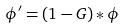Convert formula to latex. <formula><loc_0><loc_0><loc_500><loc_500>\phi ^ { \prime } = ( 1 - G ) * \phi</formula> 